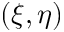<formula> <loc_0><loc_0><loc_500><loc_500>( \xi , \eta )</formula> 